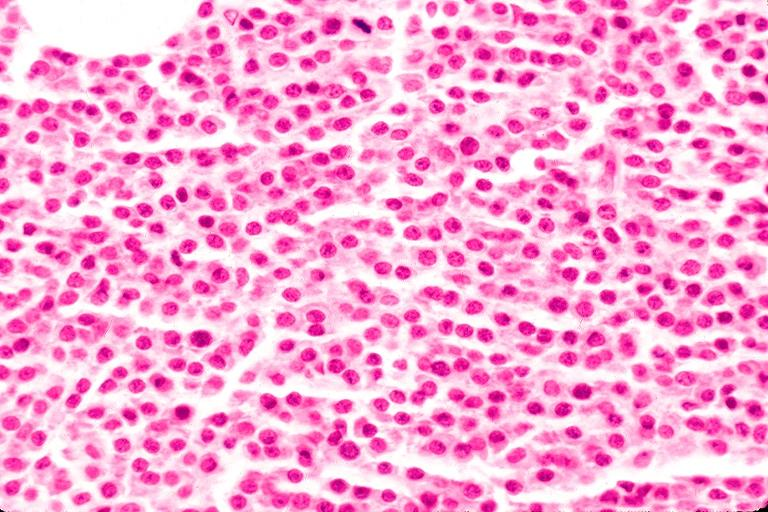s oral present?
Answer the question using a single word or phrase. Yes 